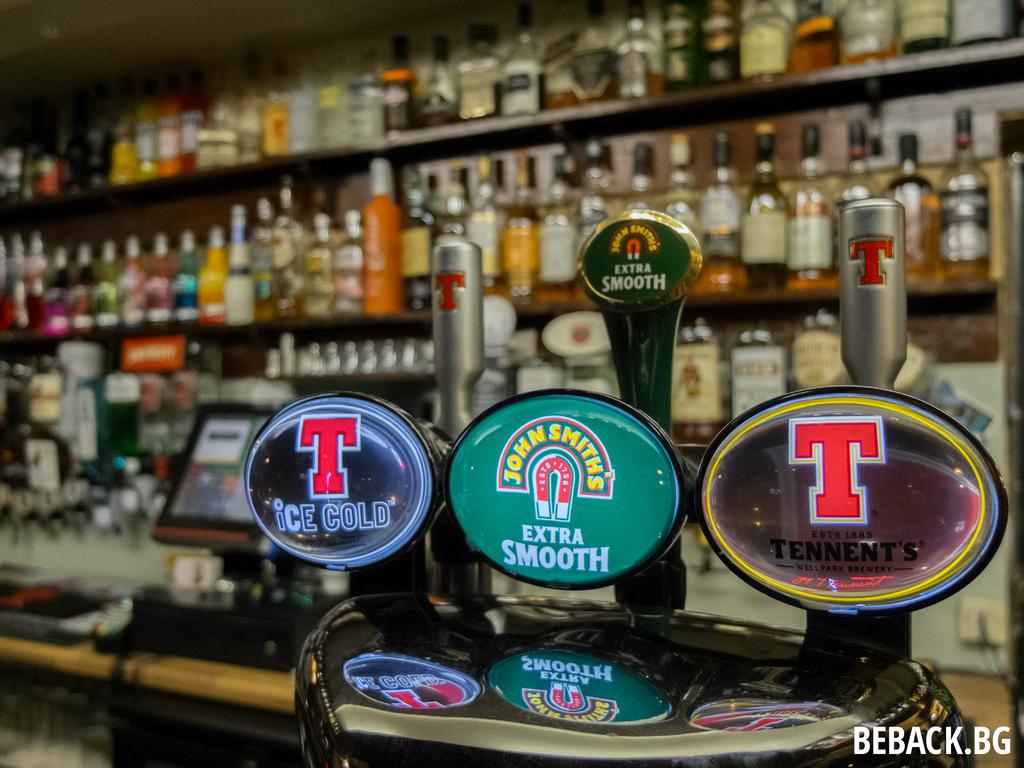What brand is listed in the green middle?
Give a very brief answer. John smith's. What is the large red letter?
Provide a short and direct response. T. 